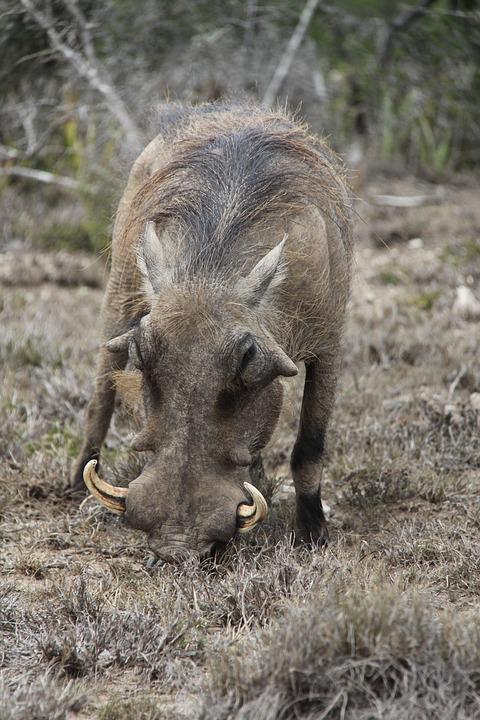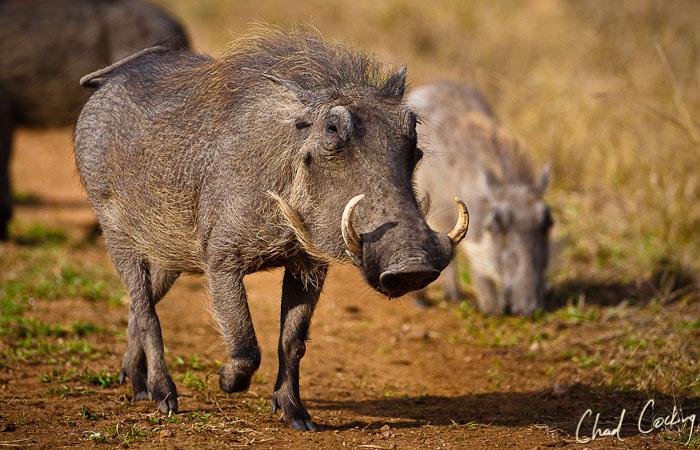The first image is the image on the left, the second image is the image on the right. Given the left and right images, does the statement "There are at most four warthogs." hold true? Answer yes or no. Yes. 